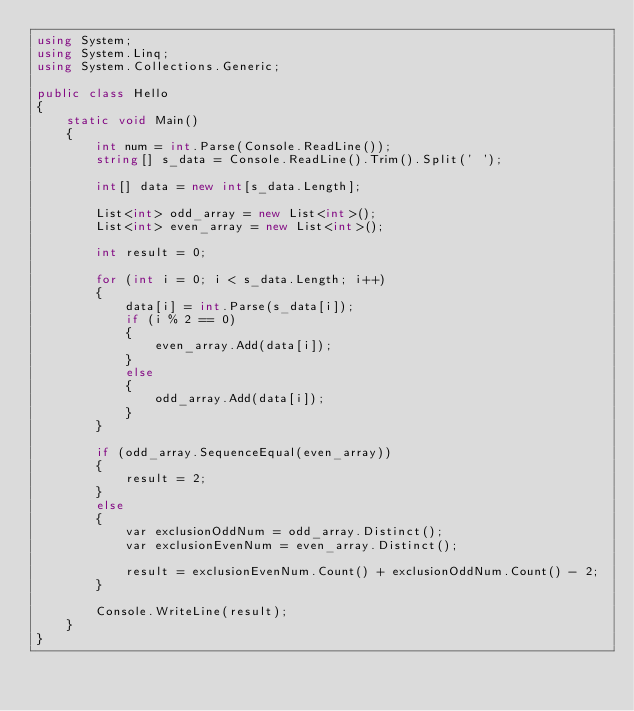Convert code to text. <code><loc_0><loc_0><loc_500><loc_500><_C#_>using System;
using System.Linq;
using System.Collections.Generic;

public class Hello
{
    static void Main()
    {
        int num = int.Parse(Console.ReadLine());
        string[] s_data = Console.ReadLine().Trim().Split(' ');

        int[] data = new int[s_data.Length];

        List<int> odd_array = new List<int>();
        List<int> even_array = new List<int>();

        int result = 0;

        for (int i = 0; i < s_data.Length; i++)
        {
            data[i] = int.Parse(s_data[i]);
            if (i % 2 == 0)
            {
                even_array.Add(data[i]);
            }
            else
            {
                odd_array.Add(data[i]);
            }
        }

        if (odd_array.SequenceEqual(even_array))
        {
            result = 2;
        }
        else
        { 
            var exclusionOddNum = odd_array.Distinct();
            var exclusionEvenNum = even_array.Distinct();

            result = exclusionEvenNum.Count() + exclusionOddNum.Count() - 2;
        }

        Console.WriteLine(result);
    }
}</code> 